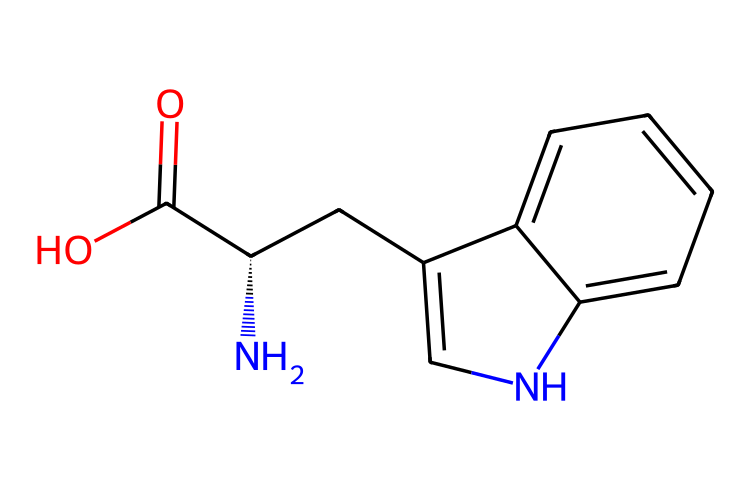How many carbon atoms are in this molecule? By examining the SMILES representation, "N[C@@H](CC1=CNC2=CC=CC=C21)C(=O)O", we count the carbon atoms directly. The main structure indicates several carbon rings and chains. There are 11 carbon atoms visible in total.
Answer: 11 What is the functional group at the end of this molecule? The last part of the SMILES, "C(=O)O", indicates the presence of a carboxylic acid with the carbonyl (C=O) and hydroxyl (O) group, which are characteristic of the carboxylic acid functional group.
Answer: carboxylic acid What type of compound is this chemical considered? The presence of an amino group (NH2), a carboxylic acid group (C(=O)O), and the structure indicating the presence of an indole ring indicates that this compound is an amino acid, specifically L-tryptophan.
Answer: amino acid Which atoms are involved in the amino group of this compound? In the SMILES "N[C@@H]", the nitrogen (N) is followed by a carbon (C), indicating that nitrogen is the atom involved in the amino group, along with the associated hydrogen atoms.
Answer: nitrogen What characteristic makes tryptophan essential? Tryptophan is termed essential because it cannot be synthesized by the human body and must be obtained through dietary sources. This is indicated by its structure as it is one of the amino acids required for protein synthesis.
Answer: dietary sources How many rings are present in the structure of tryptophan? By analyzing the cyclic structures present in "CC1=CNC2=CC=CC=C21", we can identify that there are two interconnected rings in tryptophan's structure which are part of the indole group.
Answer: 2 